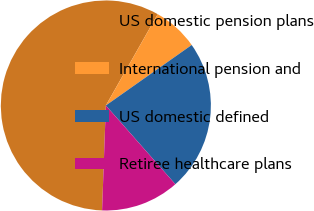Convert chart. <chart><loc_0><loc_0><loc_500><loc_500><pie_chart><fcel>US domestic pension plans<fcel>International pension and<fcel>US domestic defined<fcel>Retiree healthcare plans<nl><fcel>57.65%<fcel>7.01%<fcel>23.26%<fcel>12.08%<nl></chart> 